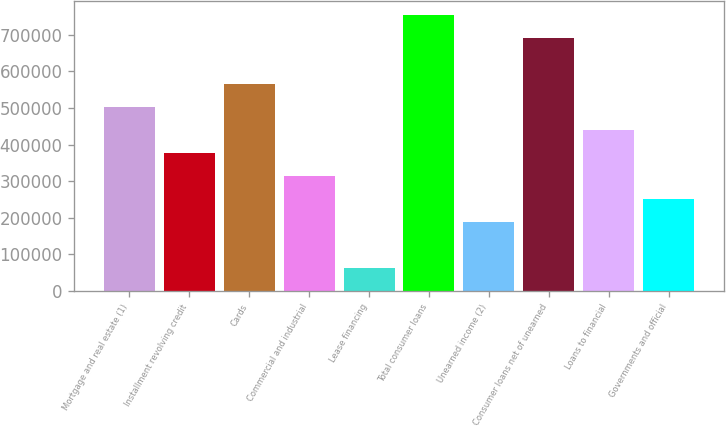Convert chart. <chart><loc_0><loc_0><loc_500><loc_500><bar_chart><fcel>Mortgage and real estate (1)<fcel>Installment revolving credit<fcel>Cards<fcel>Commercial and industrial<fcel>Lease financing<fcel>Total consumer loans<fcel>Unearned income (2)<fcel>Consumer loans net of unearned<fcel>Loans to financial<fcel>Governments and official<nl><fcel>502913<fcel>377186<fcel>565777<fcel>314322<fcel>62866.3<fcel>754369<fcel>188594<fcel>691505<fcel>440049<fcel>251458<nl></chart> 